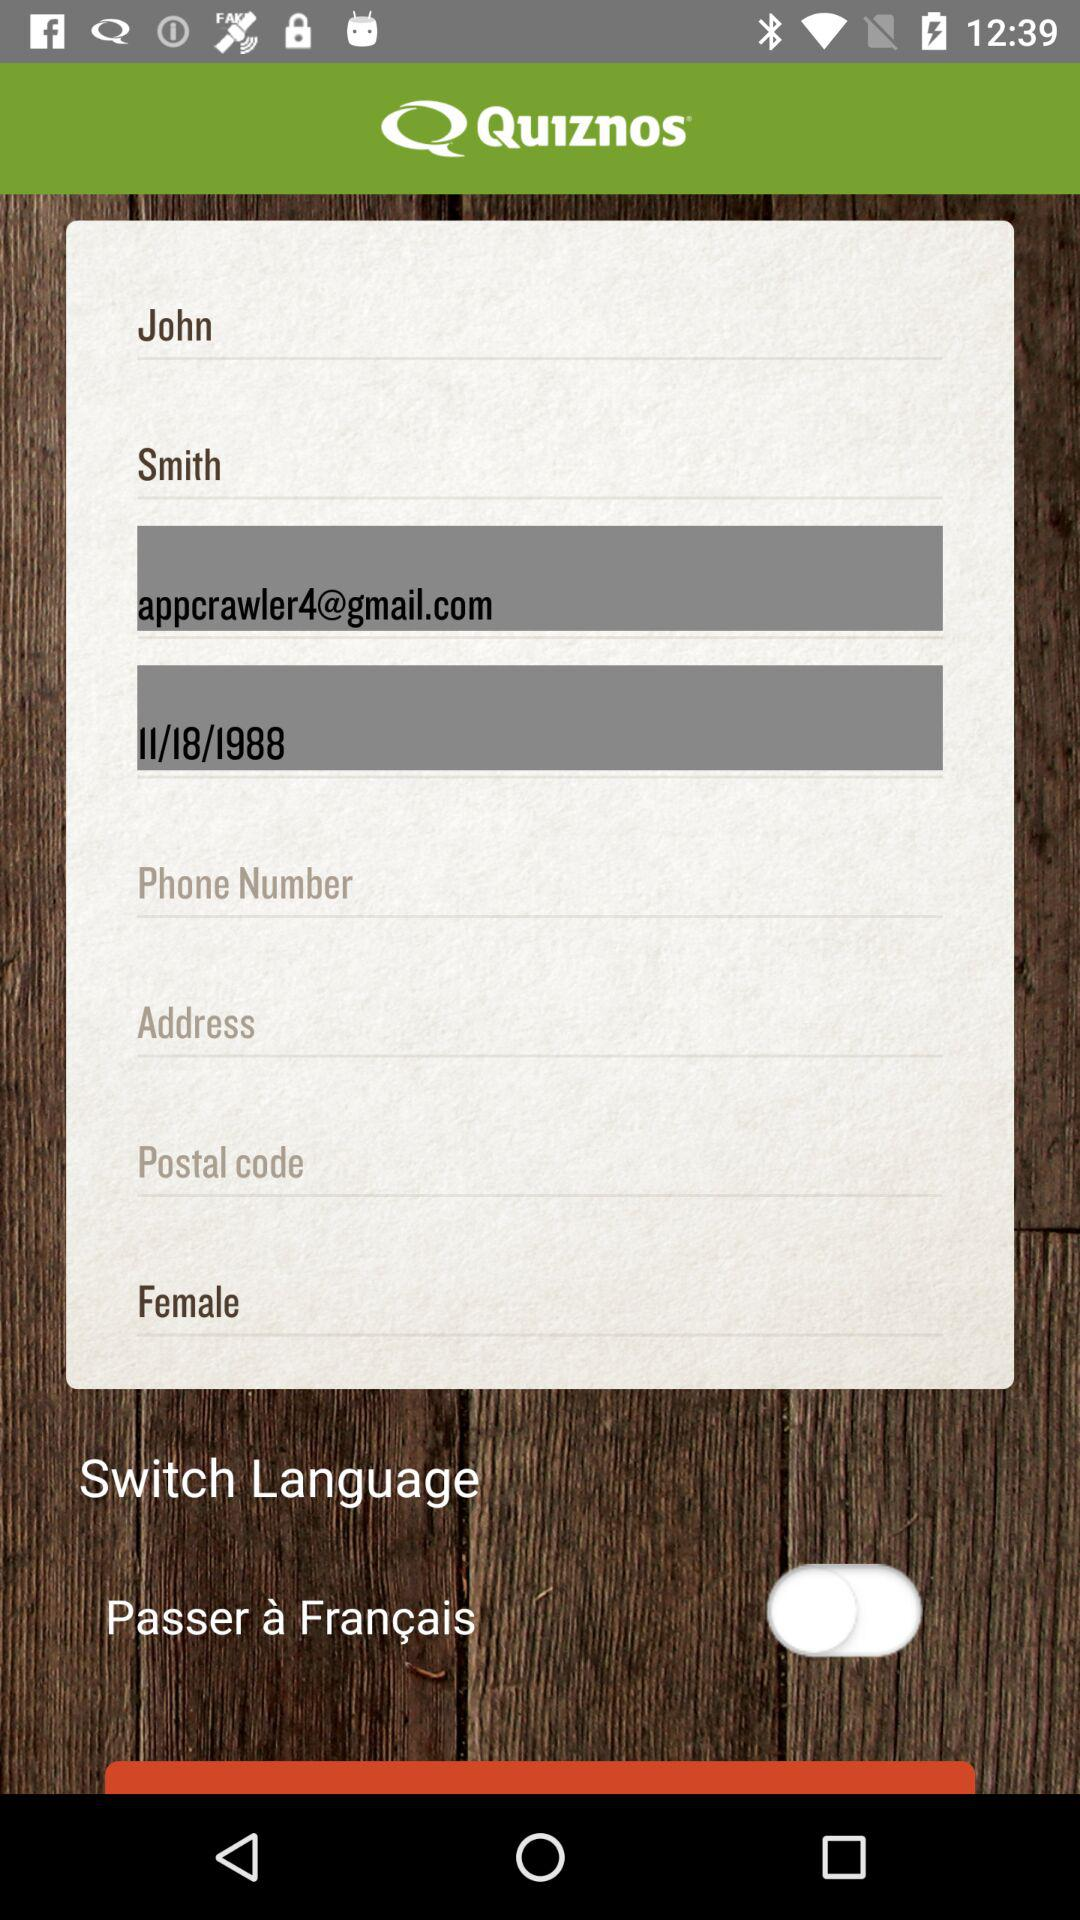What is the name of the user? The name of the user is John Smith. 